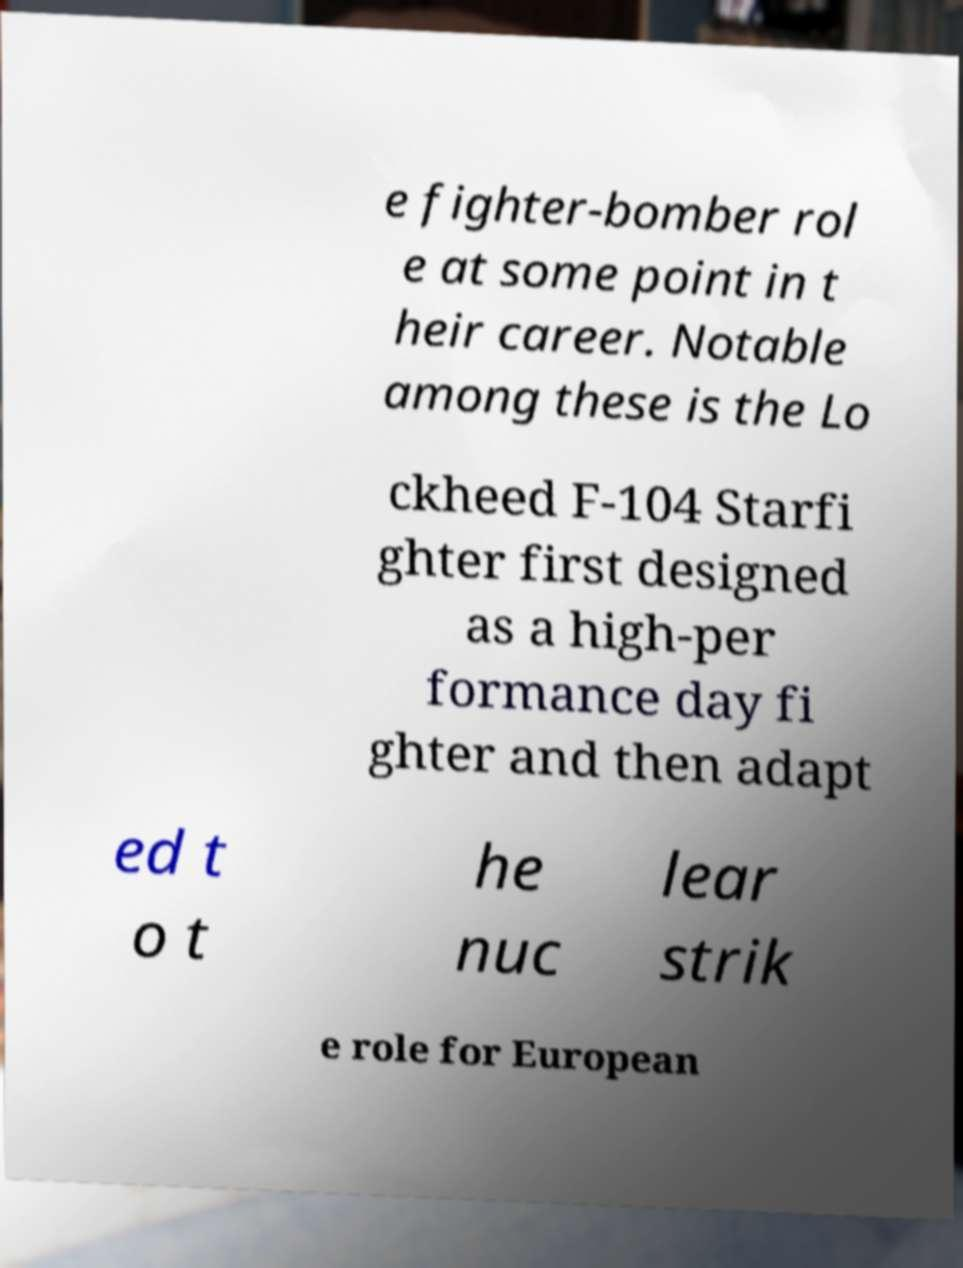What messages or text are displayed in this image? I need them in a readable, typed format. e fighter-bomber rol e at some point in t heir career. Notable among these is the Lo ckheed F-104 Starfi ghter first designed as a high-per formance day fi ghter and then adapt ed t o t he nuc lear strik e role for European 